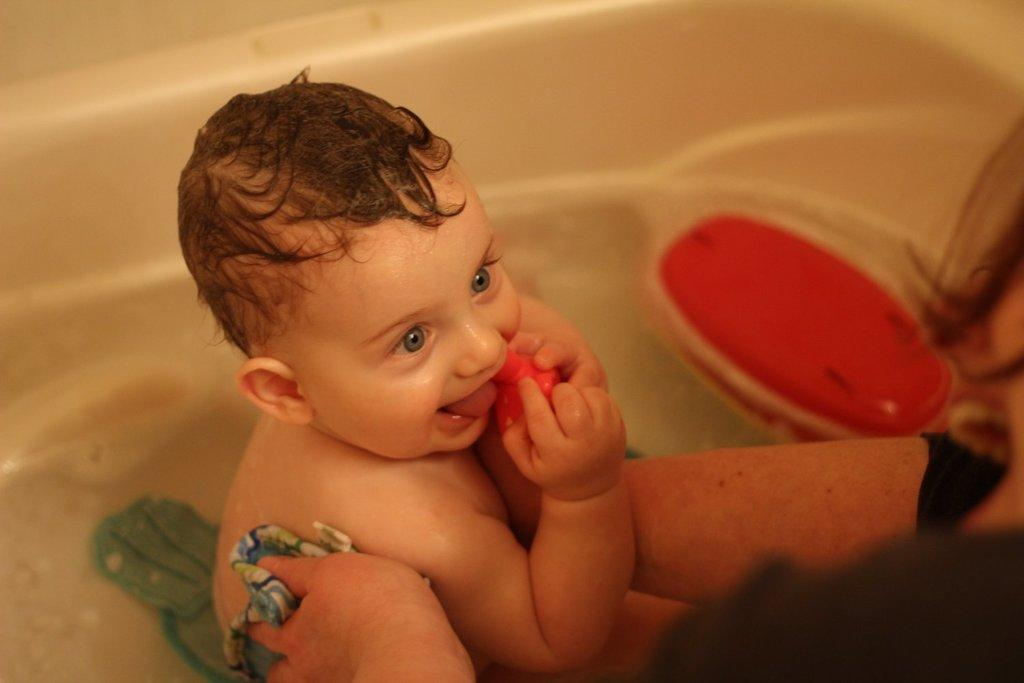What is the main subject in the image? There is a baby in the bathtub in the image. Can you describe the woman's position in the image? The woman is on the right side of the image. What type of badge is the baby wearing in the image? There is no badge visible on the baby in the image. What type of furniture is present in the image? The provided facts do not mention any furniture in the image. 